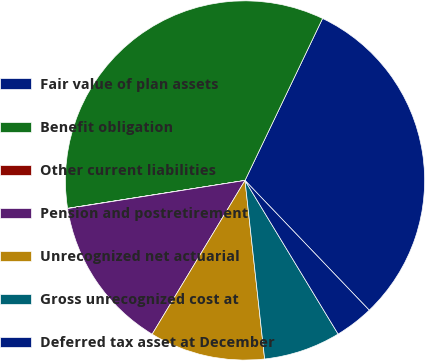Convert chart. <chart><loc_0><loc_0><loc_500><loc_500><pie_chart><fcel>Fair value of plan assets<fcel>Benefit obligation<fcel>Other current liabilities<fcel>Pension and postretirement<fcel>Unrecognized net actuarial<fcel>Gross unrecognized cost at<fcel>Deferred tax asset at December<nl><fcel>30.74%<fcel>34.59%<fcel>0.02%<fcel>13.85%<fcel>10.39%<fcel>6.93%<fcel>3.48%<nl></chart> 